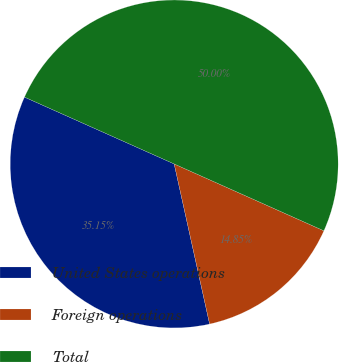Convert chart. <chart><loc_0><loc_0><loc_500><loc_500><pie_chart><fcel>United States operations<fcel>Foreign operations<fcel>Total<nl><fcel>35.15%<fcel>14.85%<fcel>50.0%<nl></chart> 